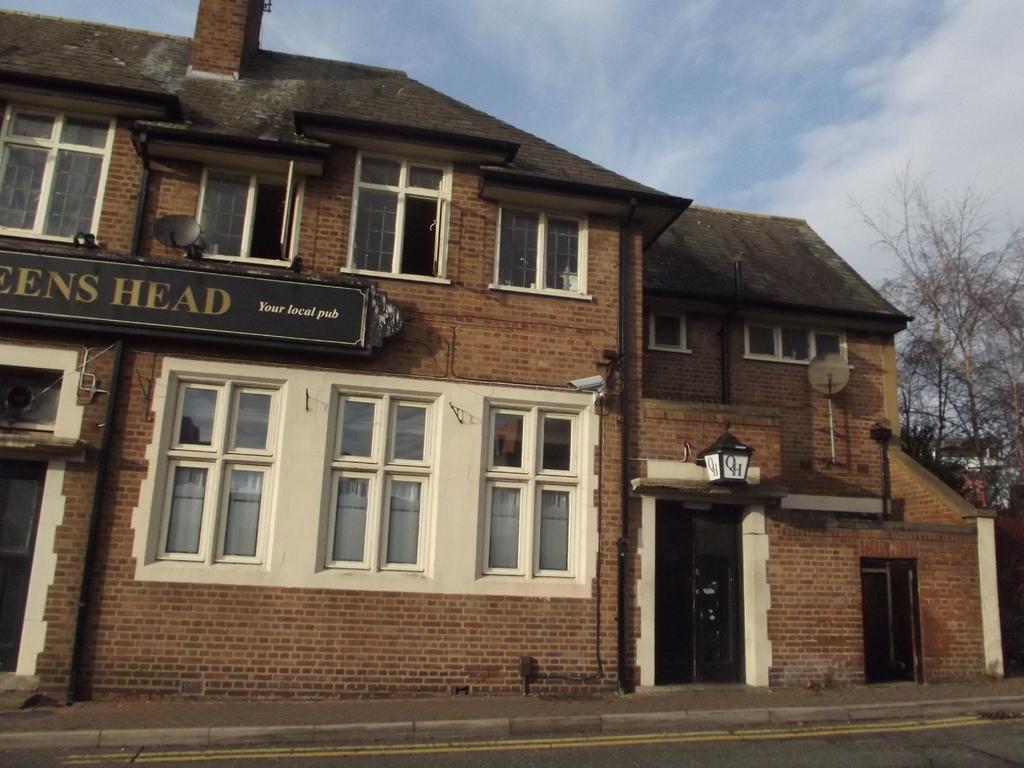How would you summarize this image in a sentence or two? In this image we can see a building with windows, group of poles, CCTV camera and satellite dish on the wall. On the right side of the image we can see some trees. In the background, we can see the cloudy sky. 